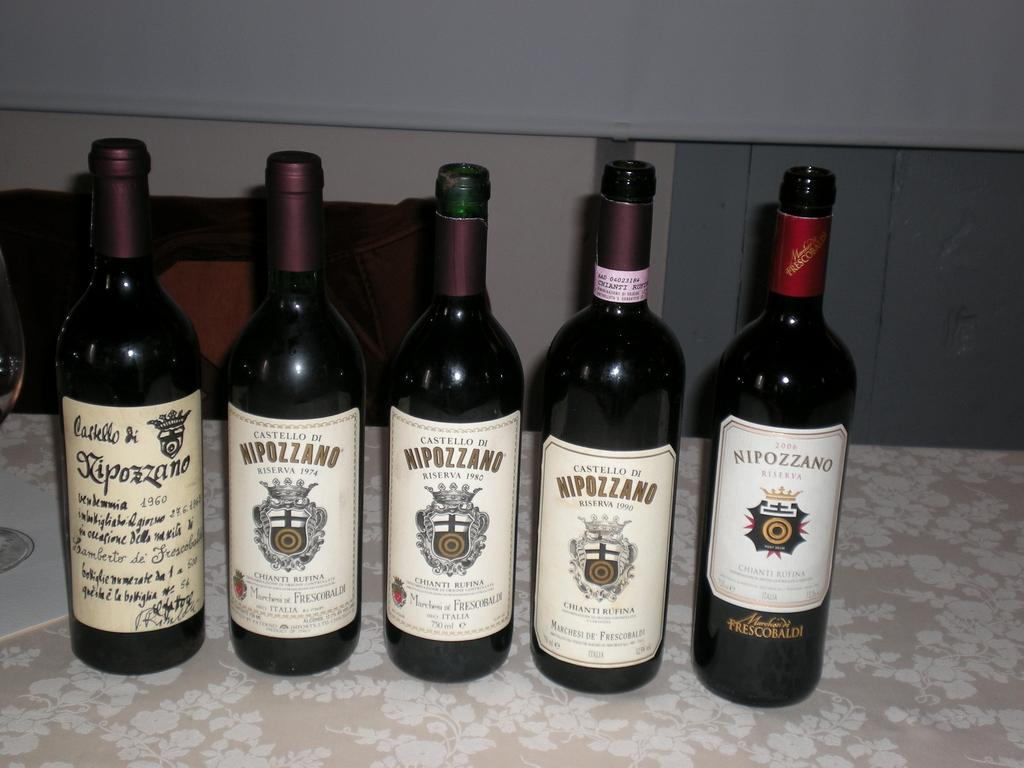<image>
Offer a succinct explanation of the picture presented. Many bottles of Nipozzano are on a table. 